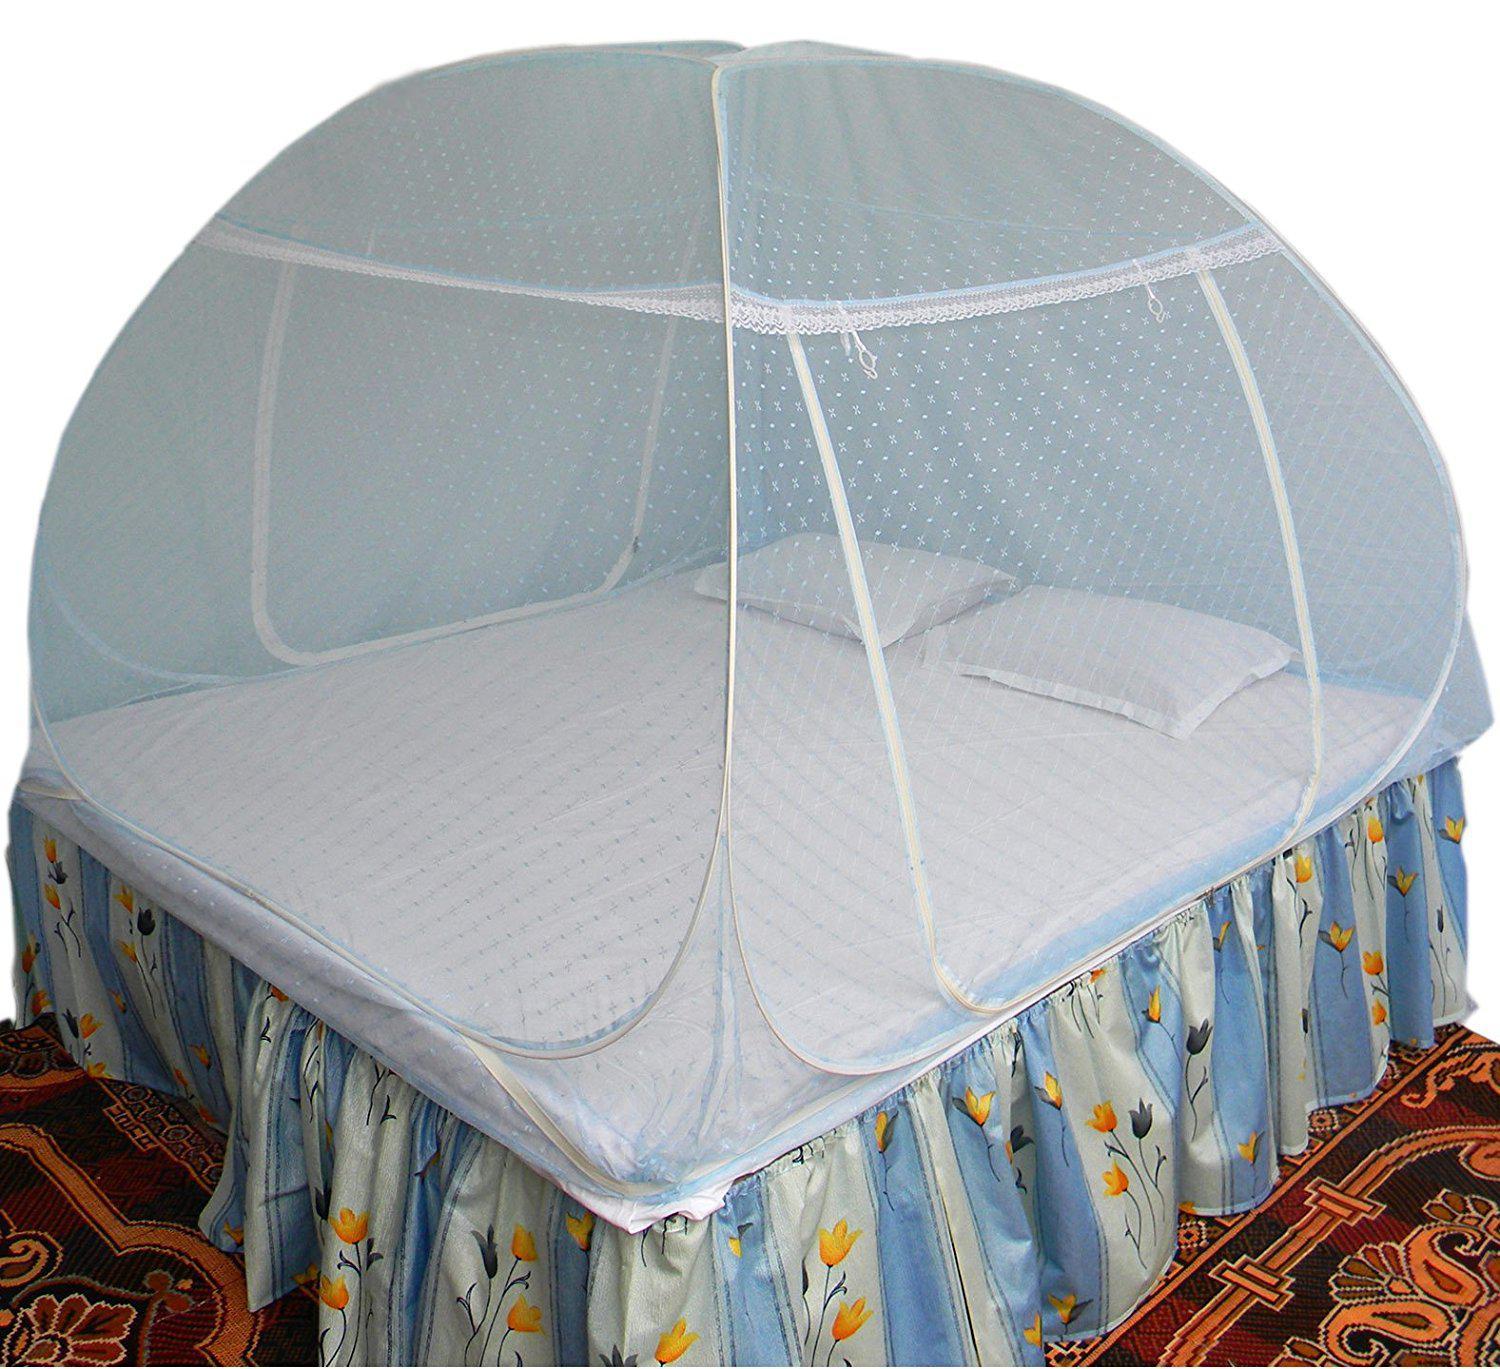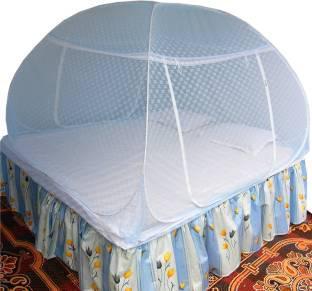The first image is the image on the left, the second image is the image on the right. For the images shown, is this caption "Both beds have headboards." true? Answer yes or no. No. 